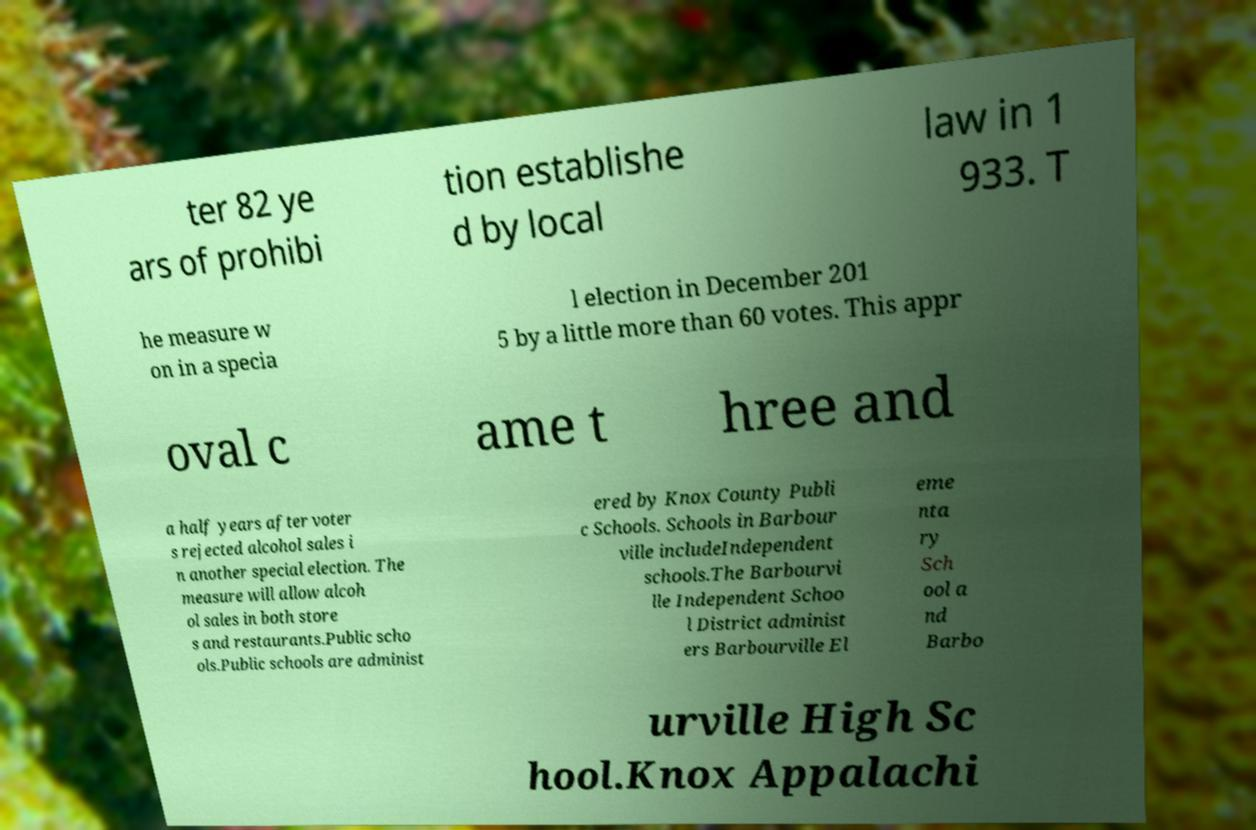Can you read and provide the text displayed in the image?This photo seems to have some interesting text. Can you extract and type it out for me? ter 82 ye ars of prohibi tion establishe d by local law in 1 933. T he measure w on in a specia l election in December 201 5 by a little more than 60 votes. This appr oval c ame t hree and a half years after voter s rejected alcohol sales i n another special election. The measure will allow alcoh ol sales in both store s and restaurants.Public scho ols.Public schools are administ ered by Knox County Publi c Schools. Schools in Barbour ville includeIndependent schools.The Barbourvi lle Independent Schoo l District administ ers Barbourville El eme nta ry Sch ool a nd Barbo urville High Sc hool.Knox Appalachi 